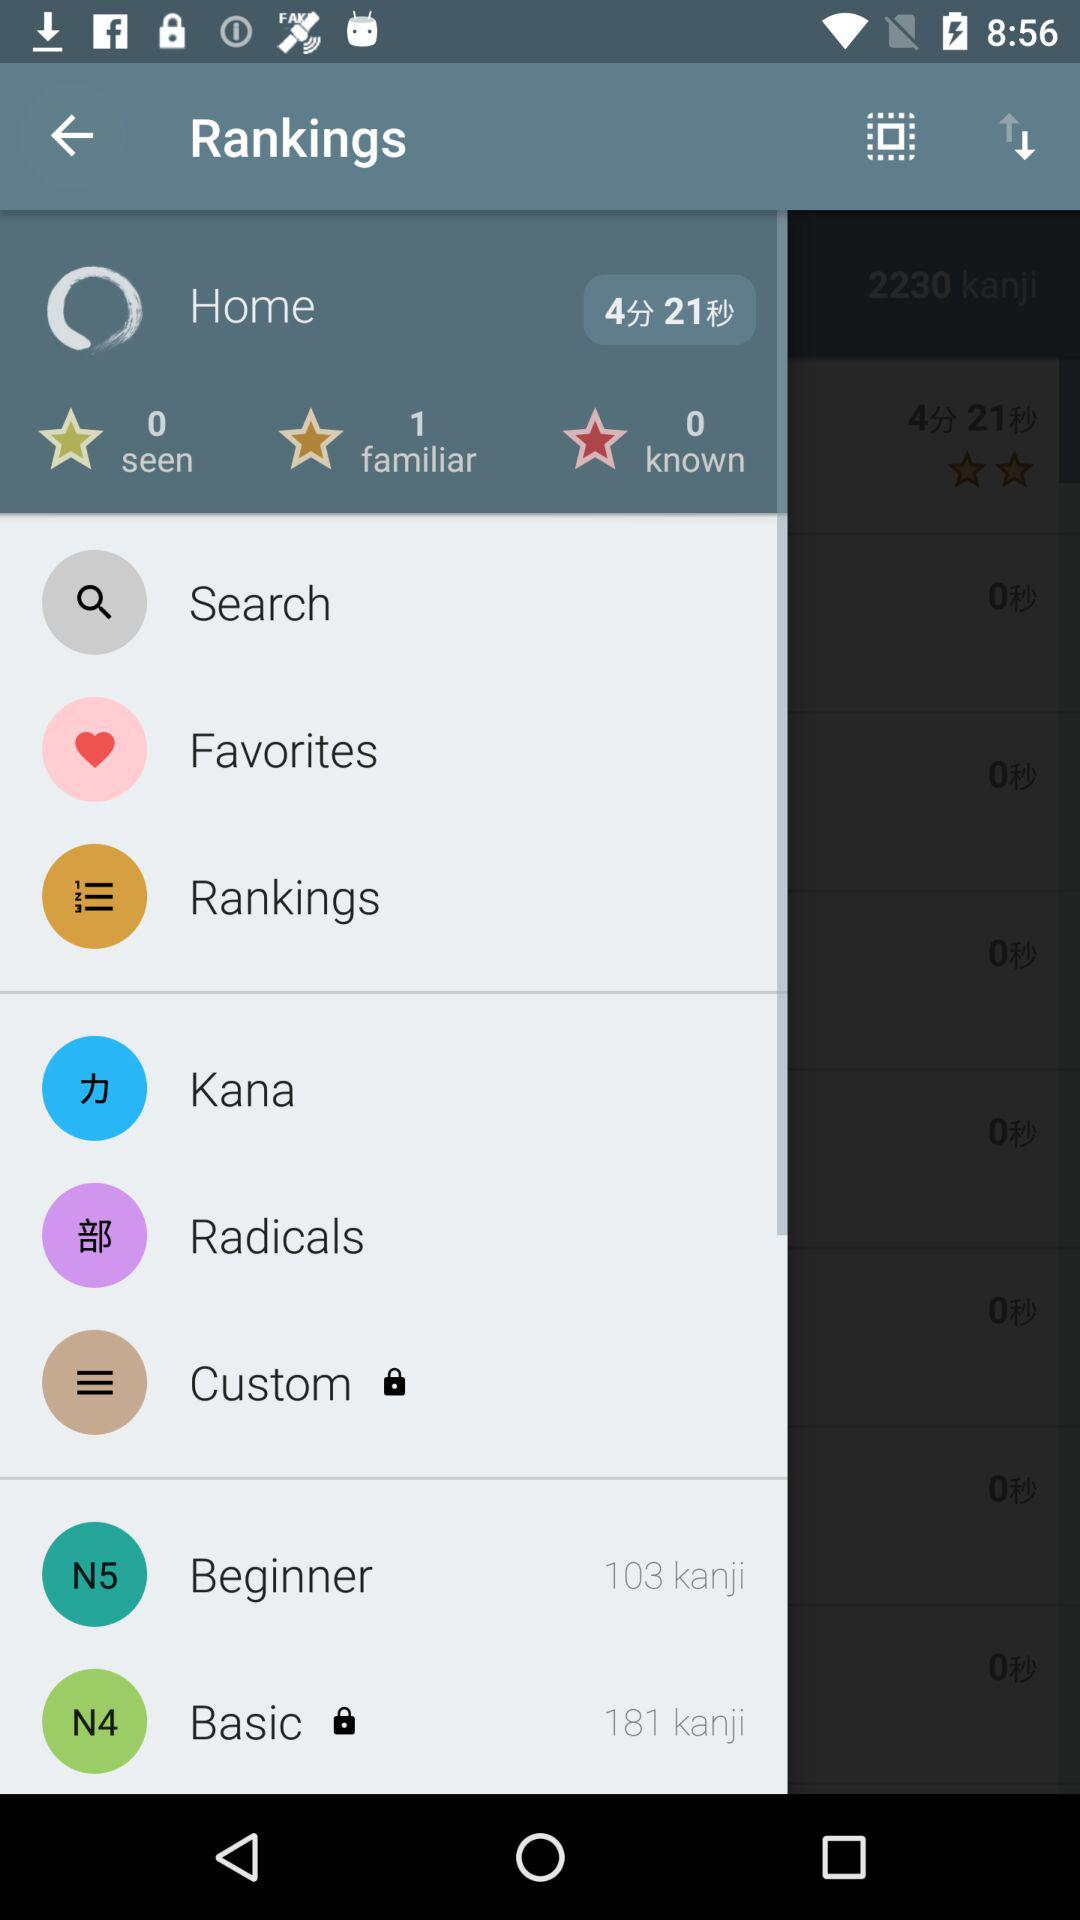How many more kanji are in the Beginner level than the Basic level?
Answer the question using a single word or phrase. 78 